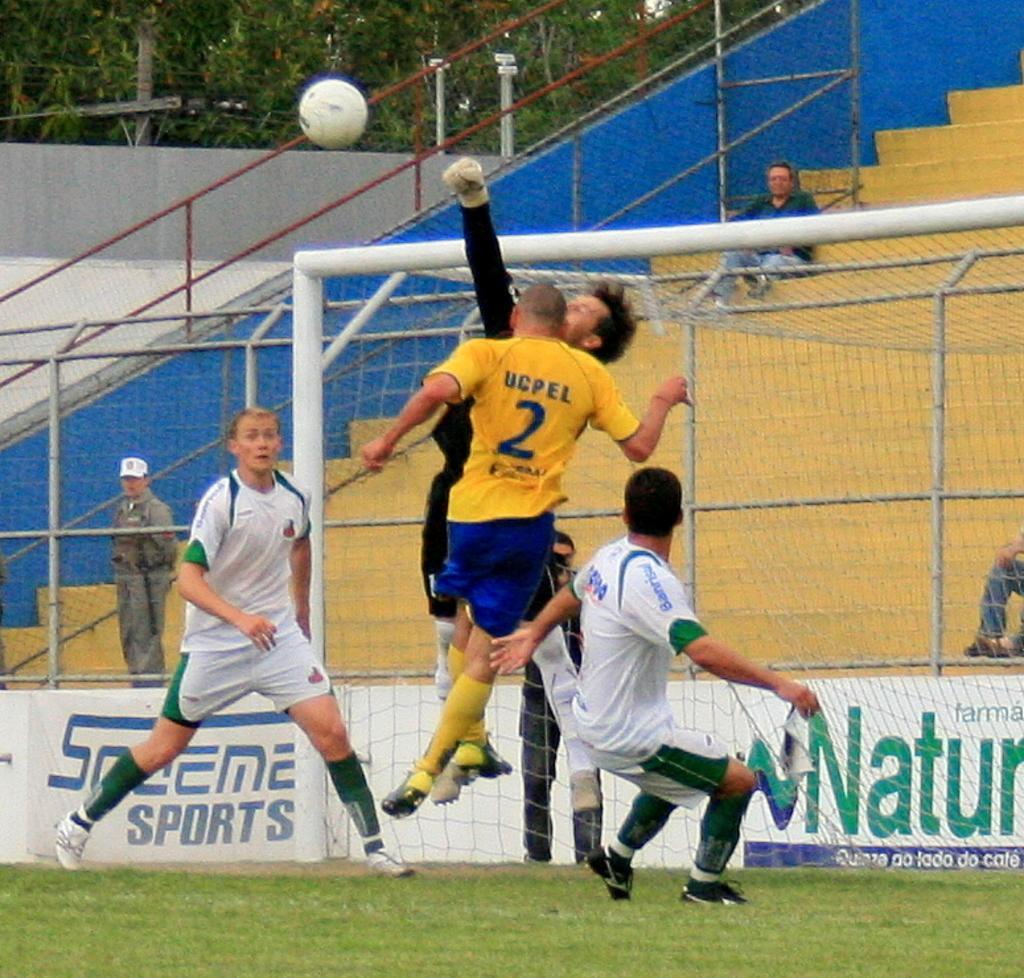Can you describe this image briefly? In the middle a person is jumping he wore a yellow color t-shirt, in the left side a man is running, he wore white color dress. In the air it's a ball which is in white color. 